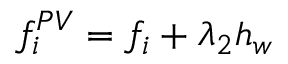Convert formula to latex. <formula><loc_0><loc_0><loc_500><loc_500>f _ { i } ^ { P V } = f _ { i } + \lambda _ { 2 } h _ { w }</formula> 